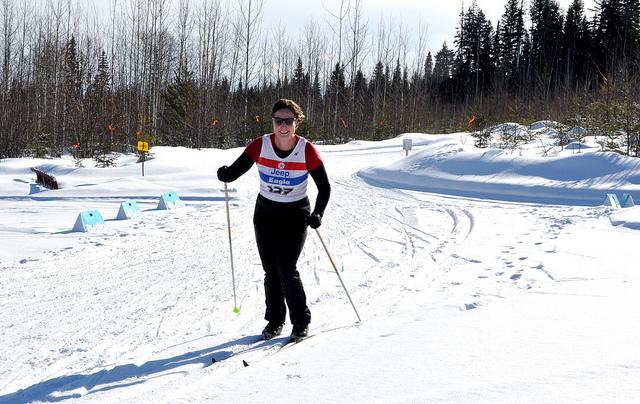What is covering the ground?
Give a very brief answer. Snow. Does she look like a professional skier?
Quick response, please. Yes. What is the sponsors name on her Jersey?
Be succinct. Jeep. 